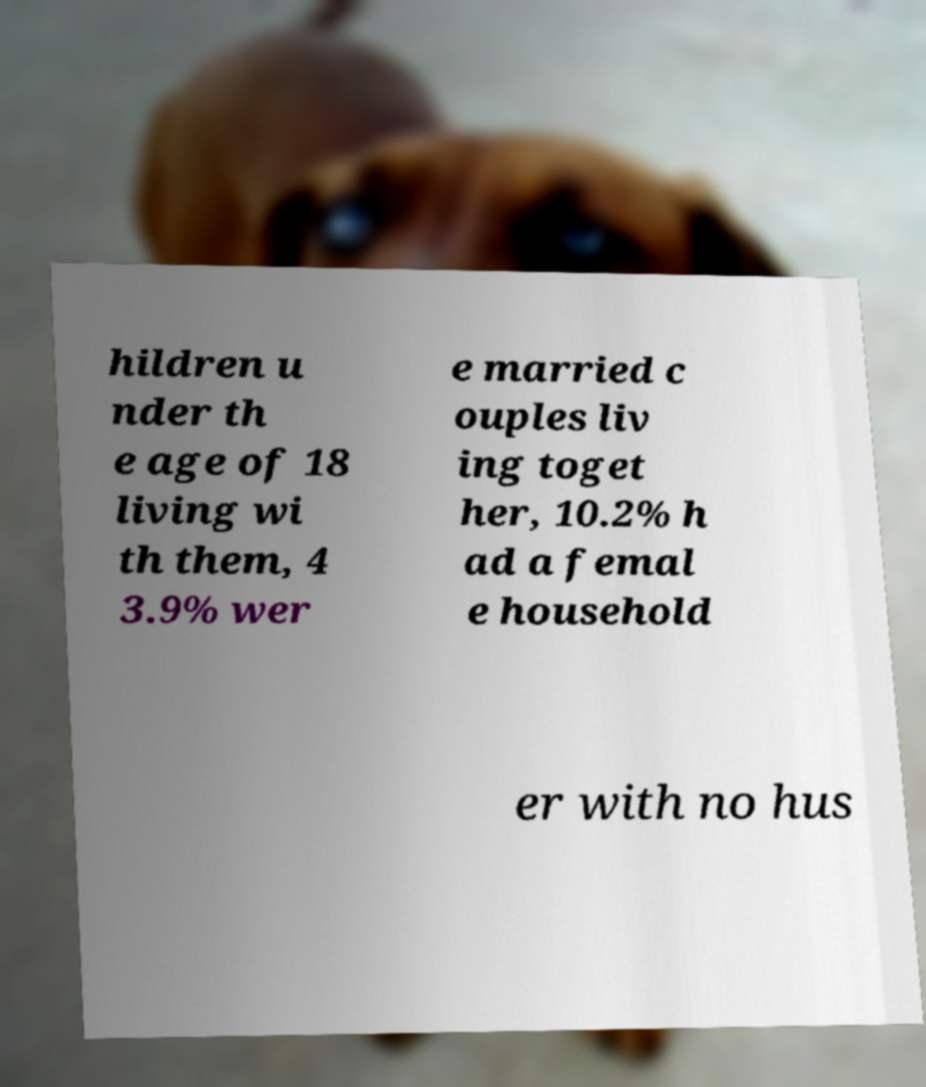Can you accurately transcribe the text from the provided image for me? hildren u nder th e age of 18 living wi th them, 4 3.9% wer e married c ouples liv ing toget her, 10.2% h ad a femal e household er with no hus 